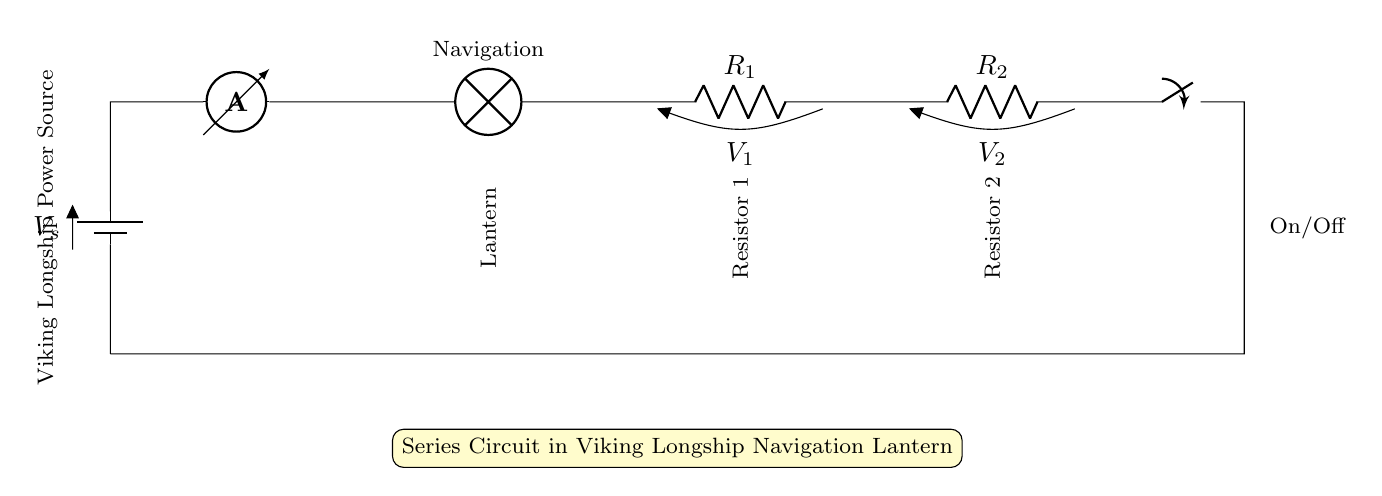What is the power source type in the circuit? The power source is a battery, indicated by the symbol labeled V_s at the start of the circuit.
Answer: Battery What is the current measurement tool in the circuit? The ammeter is clearly marked in the diagram and is used for measuring the current flowing through the circuit.
Answer: Ammeter How many resistors are present in the circuit? There are two resistors marked R_1 and R_2 in the series circuit, so the count is straightforward.
Answer: Two What is the component labeled 'Lamp' used for? The lamp is referred to as the navigation lantern, indicating it likely serves the purpose of lighting in the circuit.
Answer: Navigation Lantern What happens if the switch is turned off? Turning off the switch would break the circuit, stopping current flow and turning off the navigation lantern.
Answer: Current stops What is the arrangement of the components in the circuit? The components are arranged in a series configuration where each component is connected one after the other, forming a single path for current flow.
Answer: Series What is the function of the resistors in this circuit? The resistors limit the current flowing to the navigation lantern, protecting it from excessive current that could cause damage.
Answer: Current Limiting 